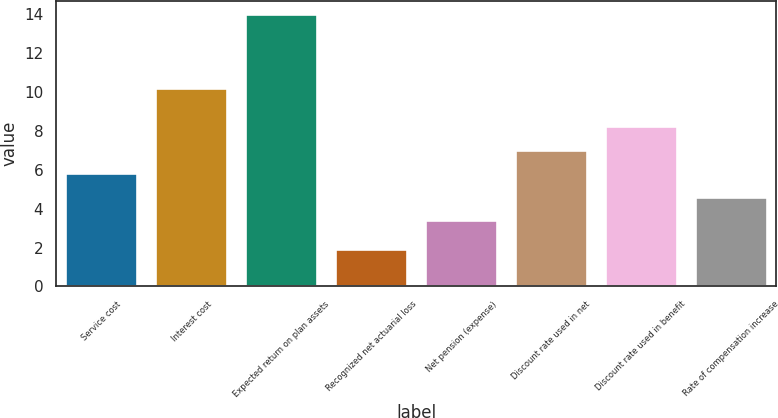Convert chart. <chart><loc_0><loc_0><loc_500><loc_500><bar_chart><fcel>Service cost<fcel>Interest cost<fcel>Expected return on plan assets<fcel>Recognized net actuarial loss<fcel>Net pension (expense)<fcel>Discount rate used in net<fcel>Discount rate used in benefit<fcel>Rate of compensation increase<nl><fcel>5.82<fcel>10.2<fcel>14<fcel>1.9<fcel>3.4<fcel>7.03<fcel>8.24<fcel>4.61<nl></chart> 